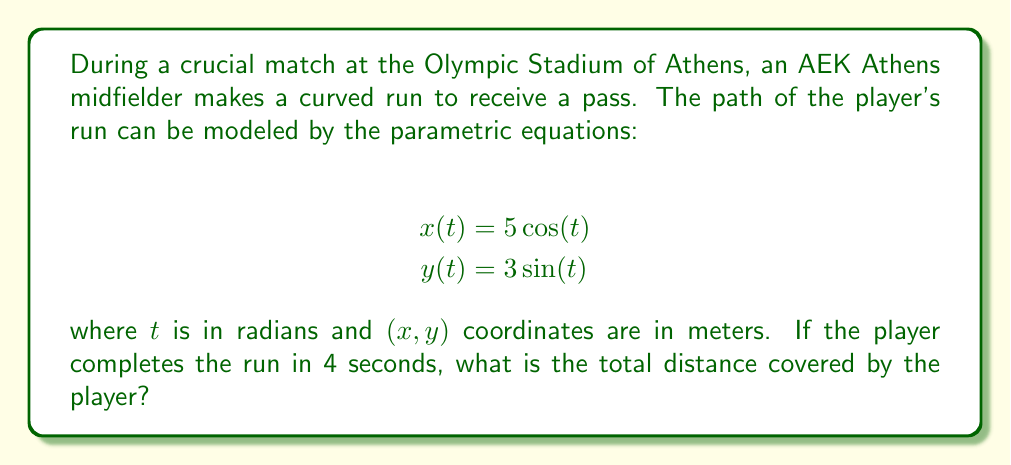Solve this math problem. To solve this problem, we need to follow these steps:

1) The path described by the parametric equations is an ellipse. To find the distance traveled, we need to calculate the arc length of this ellipse.

2) The arc length formula for parametric equations is:

   $$L = \int_a^b \sqrt{\left(\frac{dx}{dt}\right)^2 + \left(\frac{dy}{dt}\right)^2} dt$$

3) Let's find $\frac{dx}{dt}$ and $\frac{dy}{dt}$:
   
   $$\frac{dx}{dt} = -5\sin(t)$$
   $$\frac{dy}{dt} = 3\cos(t)$$

4) Substituting into the arc length formula:

   $$L = \int_a^b \sqrt{(-5\sin(t))^2 + (3\cos(t))^2} dt$$
   $$L = \int_a^b \sqrt{25\sin^2(t) + 9\cos^2(t)} dt$$

5) This integral doesn't have an elementary antiderivative. We need to use the approximation for the perimeter of an ellipse:

   $$L \approx 2\pi\sqrt{\frac{a^2 + b^2}{2}}$$

   where $a$ and $b$ are the semi-major and semi-minor axes of the ellipse.

6) In this case, $a = 5$ and $b = 3$. Substituting:

   $$L \approx 2\pi\sqrt{\frac{5^2 + 3^2}{2}} = 2\pi\sqrt{\frac{34}{2}} = 2\pi\sqrt{17}$$

7) This gives us the total length of the ellipse. However, we need to find how much of this ellipse the player covers in 4 seconds.

8) The period of the parametric equations is $2\pi$. If this represents 4 seconds, then the player completes a full ellipse in 4 seconds.

Therefore, the total distance covered is approximately $2\pi\sqrt{17}$ meters.
Answer: The total distance covered by the player is approximately $2\pi\sqrt{17} \approx 25.93$ meters. 